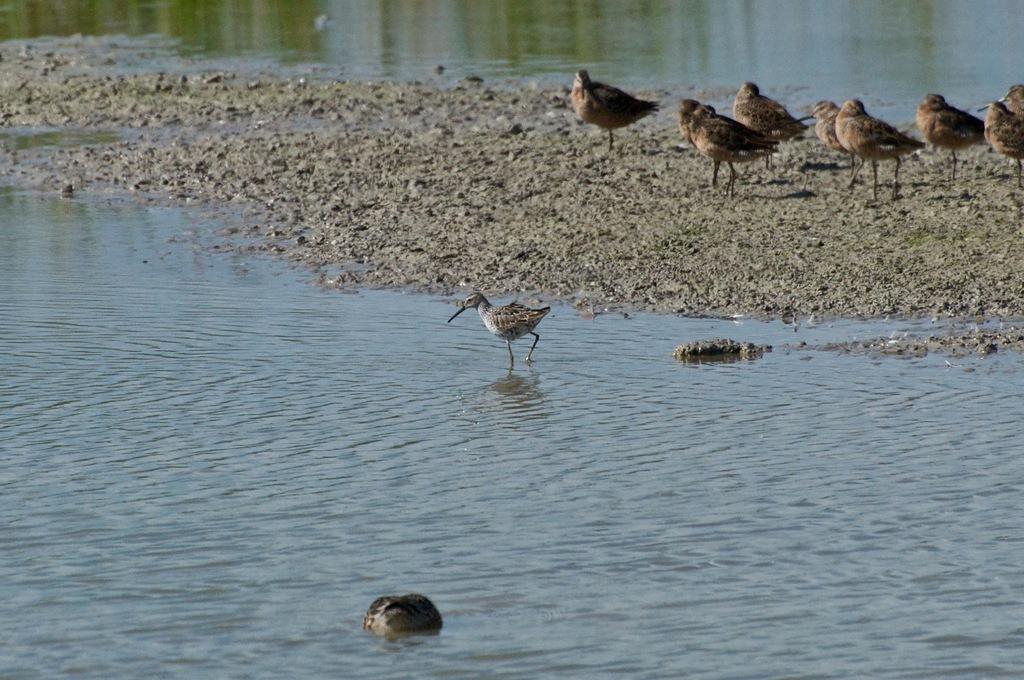How would you summarize this image in a sentence or two? In this picture, we can see water, ground, a few birds, and some object in water. 